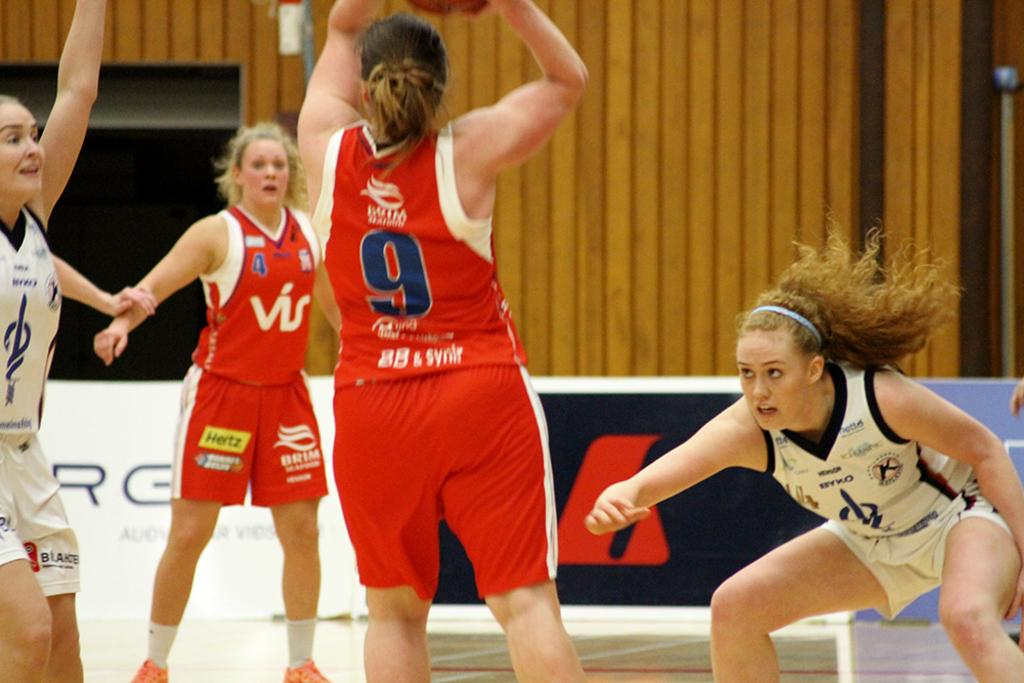<image>
Share a concise interpretation of the image provided. Some people playing sports indoors, one of them has the number 9 on her shirt. 